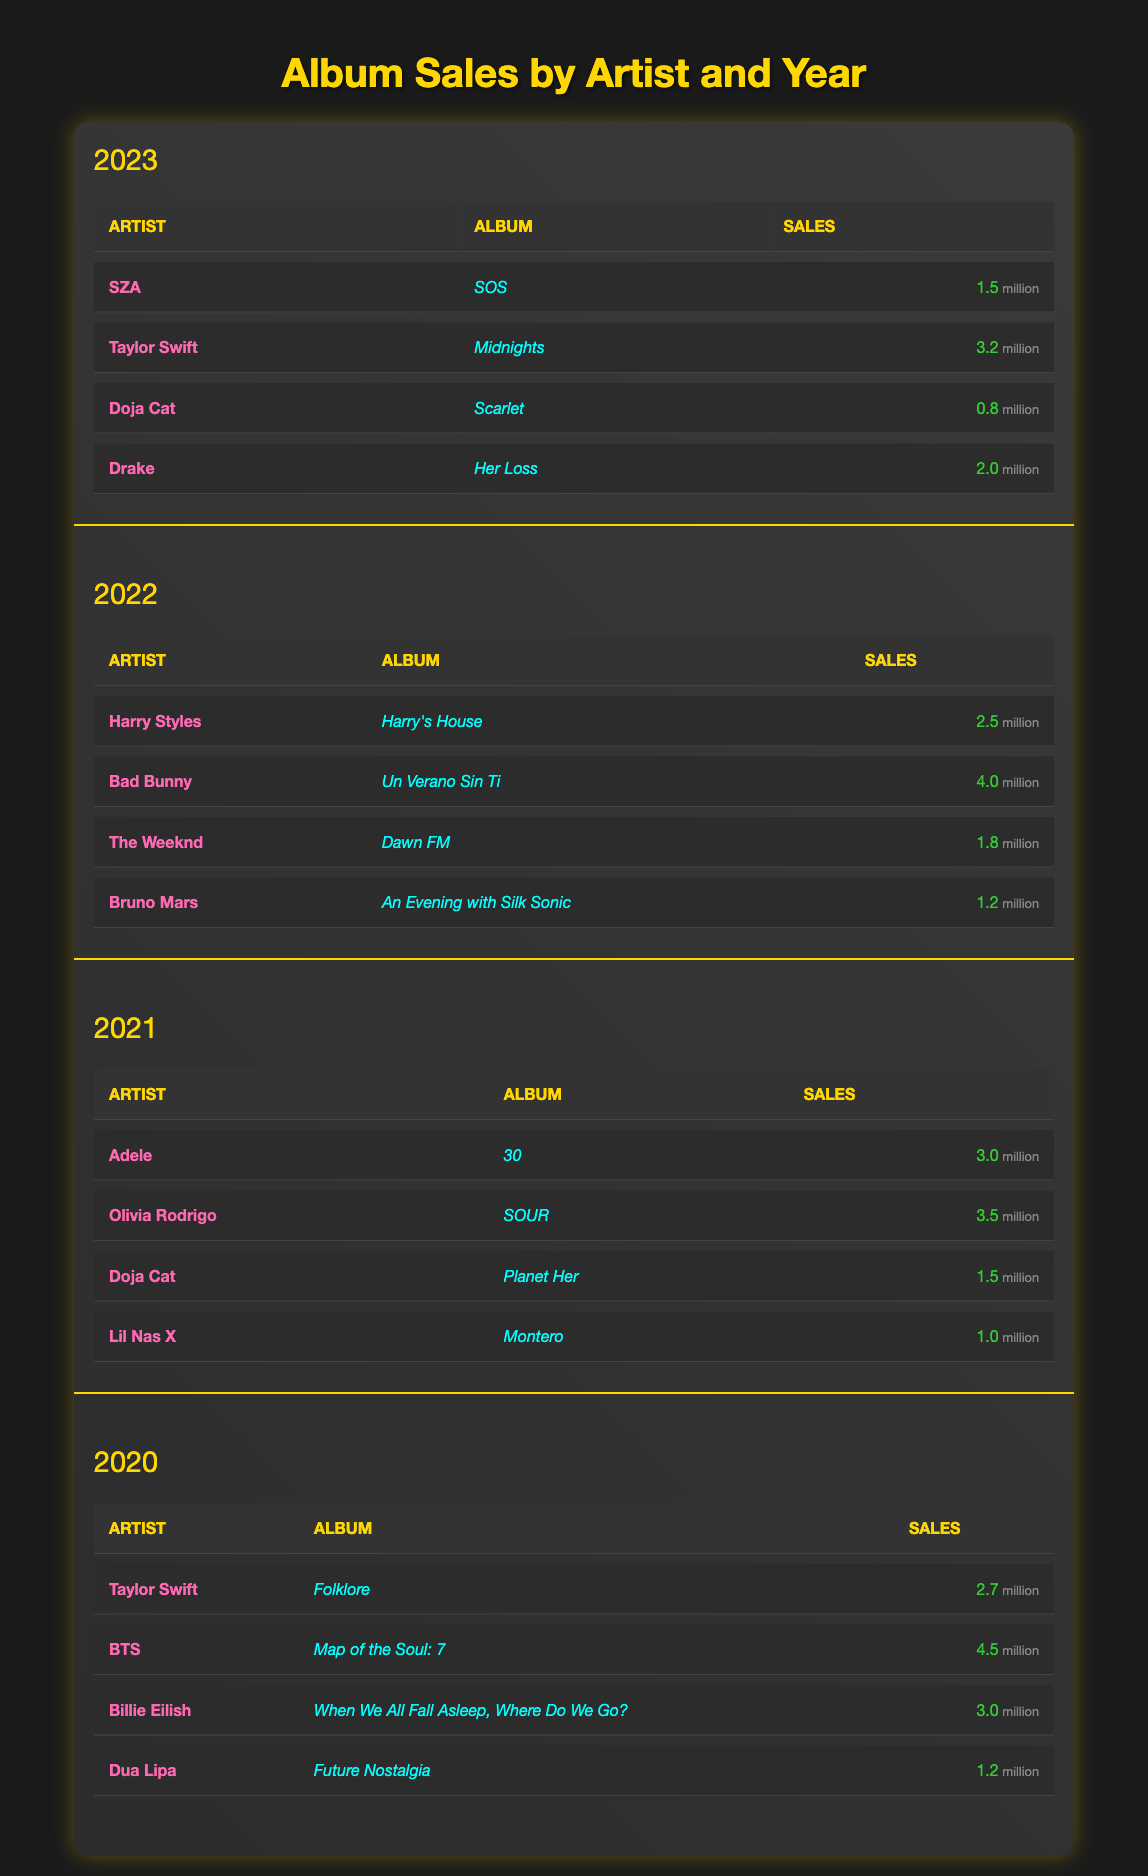What is the total album sales for BTS in 2020? According to the table, BTS sold 4.5 million albums in 2020.
Answer: 4.5 million Which album by Taylor Swift had higher sales, "Folklore" in 2020 or "Midnights" in 2023? "Folklore" had 2.7 million sales in 2020, while "Midnights" had 3.2 million sales in 2023. Since 3.2 million is greater than 2.7 million, "Midnights" had higher sales.
Answer: "Midnights" What was the average album sales of the artists in 2021? The total album sales of artists in 2021 are (3.0 + 3.5 + 1.5 + 1.0) = 9.0 million. There are 4 artists, so the average sales is 9.0 / 4 = 2.25 million.
Answer: 2.25 million Did Adele have the highest album sales in 2021? In 2021, Adele sold 3.0 million albums, while Olivia Rodrigo sold 3.5 million. Since 3.5 million is higher than 3.0 million, Adele did not have the highest sales.
Answer: No What is the total album sales from all artists in 2022? Adding the album sales of all artists in 2022 gives us (2.5 + 4.0 + 1.8 + 1.2) = 9.5 million.
Answer: 9.5 million Which artist had the lowest album sales in 2023? In 2023, Doja Cat had the lowest album sales with 0.8 million compared to others (1.5, 3.2, and 2.0 million).
Answer: Doja Cat How much more did Bad Bunny sell compared to Bruno Mars in 2022? In 2022, Bad Bunny sold 4.0 million and Bruno Mars sold 1.2 million. Thus, the difference is 4.0 - 1.2 = 2.8 million.
Answer: 2.8 million What was the total sales of all albums by Doja Cat across the years listed? Doja Cat sold 1.5 million in 2021 and 0.8 million in 2023, totaling 1.5 + 0.8 = 2.3 million.
Answer: 2.3 million Which year had the highest sales for Billie Eilish? Billie Eilish sold 3.0 million in 2020 and didn't appear in the other years, therefore 2020 had the highest sales for her.
Answer: 2020 